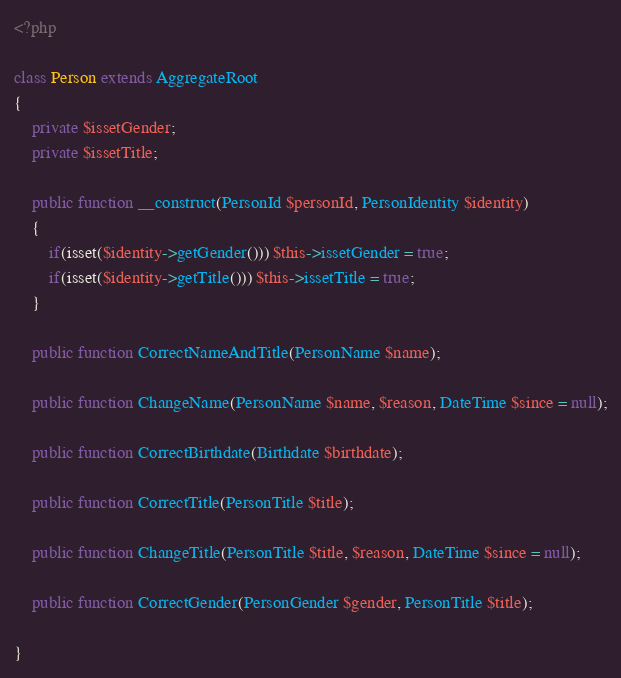Convert code to text. <code><loc_0><loc_0><loc_500><loc_500><_PHP_><?php

class Person extends AggregateRoot
{
	private $issetGender;
	private $issetTitle;
	
	public function __construct(PersonId $personId, PersonIdentity $identity)
	{
		if(isset($identity->getGender())) $this->issetGender = true;
		if(isset($identity->getTitle())) $this->issetTitle = true;
	}
	
	public function CorrectNameAndTitle(PersonName $name);
	
	public function ChangeName(PersonName $name, $reason, DateTime $since = null);
	
	public function CorrectBirthdate(Birthdate $birthdate);
	
	public function CorrectTitle(PersonTitle $title);
	
	public function ChangeTitle(PersonTitle $title, $reason, DateTime $since = null);
	
	public function CorrectGender(PersonGender $gender, PersonTitle $title);
	
}
</code> 